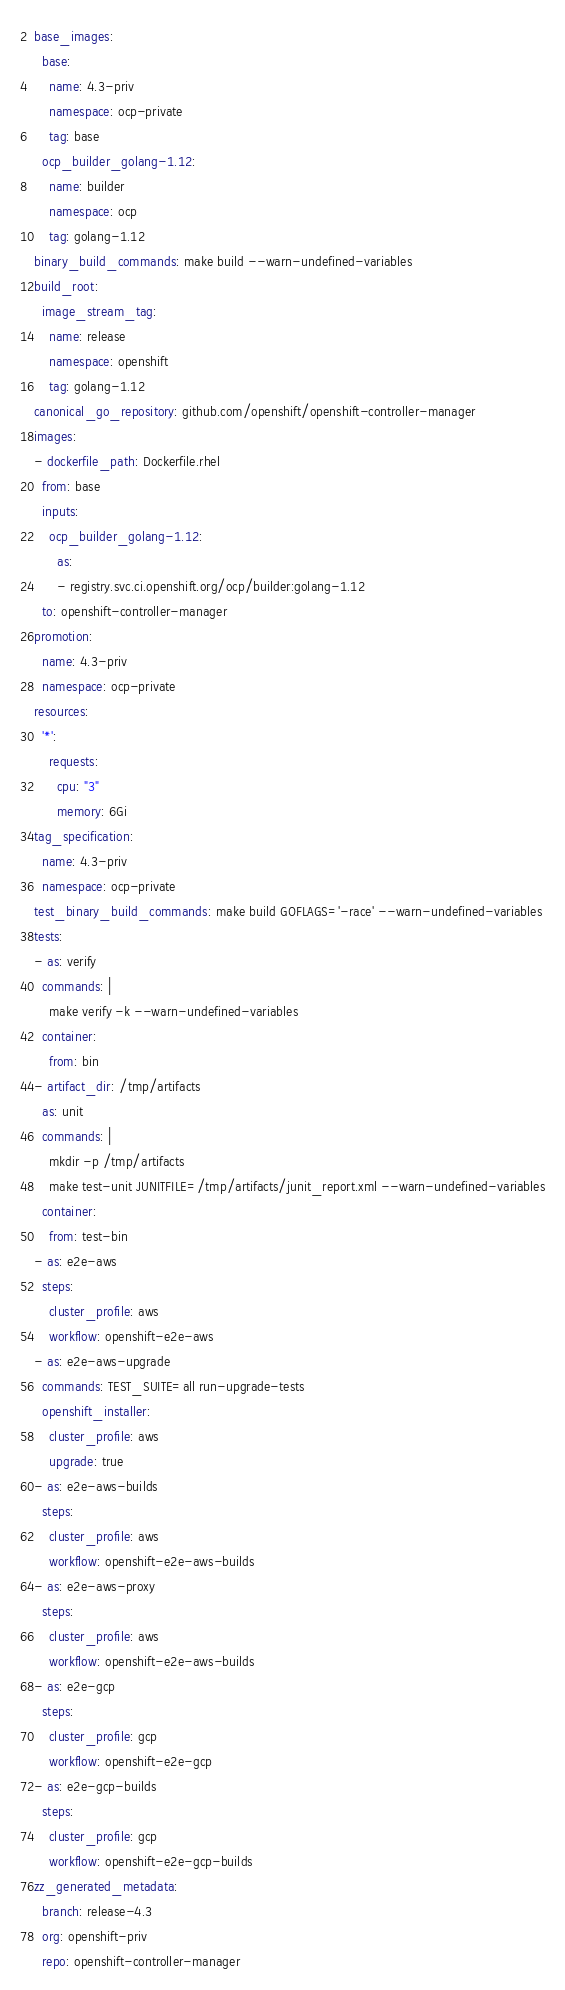<code> <loc_0><loc_0><loc_500><loc_500><_YAML_>base_images:
  base:
    name: 4.3-priv
    namespace: ocp-private
    tag: base
  ocp_builder_golang-1.12:
    name: builder
    namespace: ocp
    tag: golang-1.12
binary_build_commands: make build --warn-undefined-variables
build_root:
  image_stream_tag:
    name: release
    namespace: openshift
    tag: golang-1.12
canonical_go_repository: github.com/openshift/openshift-controller-manager
images:
- dockerfile_path: Dockerfile.rhel
  from: base
  inputs:
    ocp_builder_golang-1.12:
      as:
      - registry.svc.ci.openshift.org/ocp/builder:golang-1.12
  to: openshift-controller-manager
promotion:
  name: 4.3-priv
  namespace: ocp-private
resources:
  '*':
    requests:
      cpu: "3"
      memory: 6Gi
tag_specification:
  name: 4.3-priv
  namespace: ocp-private
test_binary_build_commands: make build GOFLAGS='-race' --warn-undefined-variables
tests:
- as: verify
  commands: |
    make verify -k --warn-undefined-variables
  container:
    from: bin
- artifact_dir: /tmp/artifacts
  as: unit
  commands: |
    mkdir -p /tmp/artifacts
    make test-unit JUNITFILE=/tmp/artifacts/junit_report.xml --warn-undefined-variables
  container:
    from: test-bin
- as: e2e-aws
  steps:
    cluster_profile: aws
    workflow: openshift-e2e-aws
- as: e2e-aws-upgrade
  commands: TEST_SUITE=all run-upgrade-tests
  openshift_installer:
    cluster_profile: aws
    upgrade: true
- as: e2e-aws-builds
  steps:
    cluster_profile: aws
    workflow: openshift-e2e-aws-builds
- as: e2e-aws-proxy
  steps:
    cluster_profile: aws
    workflow: openshift-e2e-aws-builds
- as: e2e-gcp
  steps:
    cluster_profile: gcp
    workflow: openshift-e2e-gcp
- as: e2e-gcp-builds
  steps:
    cluster_profile: gcp
    workflow: openshift-e2e-gcp-builds
zz_generated_metadata:
  branch: release-4.3
  org: openshift-priv
  repo: openshift-controller-manager
</code> 